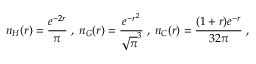<formula> <loc_0><loc_0><loc_500><loc_500>n _ { H } ( r ) = \frac { e ^ { - 2 r } } { \pi } \, , \, n _ { G } ( r ) = \frac { e ^ { - r ^ { 2 } } } { \sqrt { \pi } ^ { 3 } } \, , \, n _ { C } ( r ) = \frac { ( 1 + r ) e ^ { - r } } { 3 2 \pi } \ ,</formula> 